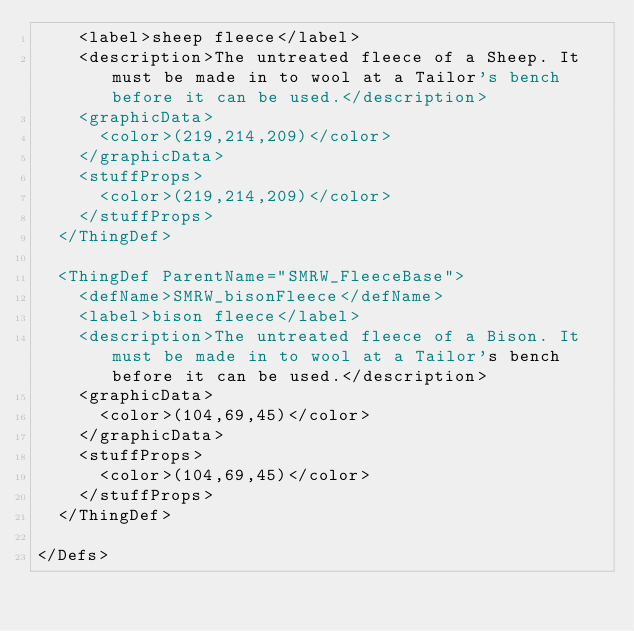<code> <loc_0><loc_0><loc_500><loc_500><_XML_>	<label>sheep fleece</label>
	<description>The untreated fleece of a Sheep. It must be made in to wool at a Tailor's bench before it can be used.</description>
    <graphicData>
      <color>(219,214,209)</color>
    </graphicData>
    <stuffProps>
      <color>(219,214,209)</color>
    </stuffProps>
  </ThingDef>
  
  <ThingDef ParentName="SMRW_FleeceBase">
    <defName>SMRW_bisonFleece</defName>
	<label>bison fleece</label>
	<description>The untreated fleece of a Bison. It must be made in to wool at a Tailor's bench before it can be used.</description>
    <graphicData>
      <color>(104,69,45)</color>
    </graphicData>
    <stuffProps>
      <color>(104,69,45)</color>
    </stuffProps>
  </ThingDef>

</Defs>

</code> 